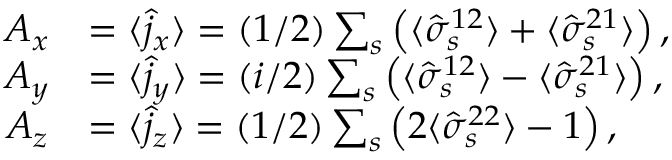Convert formula to latex. <formula><loc_0><loc_0><loc_500><loc_500>\begin{array} { r l } { A _ { x } } & { = \langle \hat { j } _ { x } \rangle = ( 1 / 2 ) \sum _ { s } \left ( \langle \hat { \sigma } _ { s } ^ { 1 2 } \rangle + \langle \hat { \sigma } _ { s } ^ { 2 1 } \rangle \right ) , } \\ { A _ { y } } & { = \langle \hat { j } _ { y } \rangle = ( i / 2 ) \sum _ { s } \left ( \langle \hat { \sigma } _ { s } ^ { 1 2 } \rangle - \langle \hat { \sigma } _ { s } ^ { 2 1 } \rangle \right ) , } \\ { A _ { z } } & { = \langle \hat { j } _ { z } \rangle = ( 1 / 2 ) \sum _ { s } \left ( 2 \langle \hat { \sigma } _ { s } ^ { 2 2 } \rangle - 1 \right ) , } \end{array}</formula> 